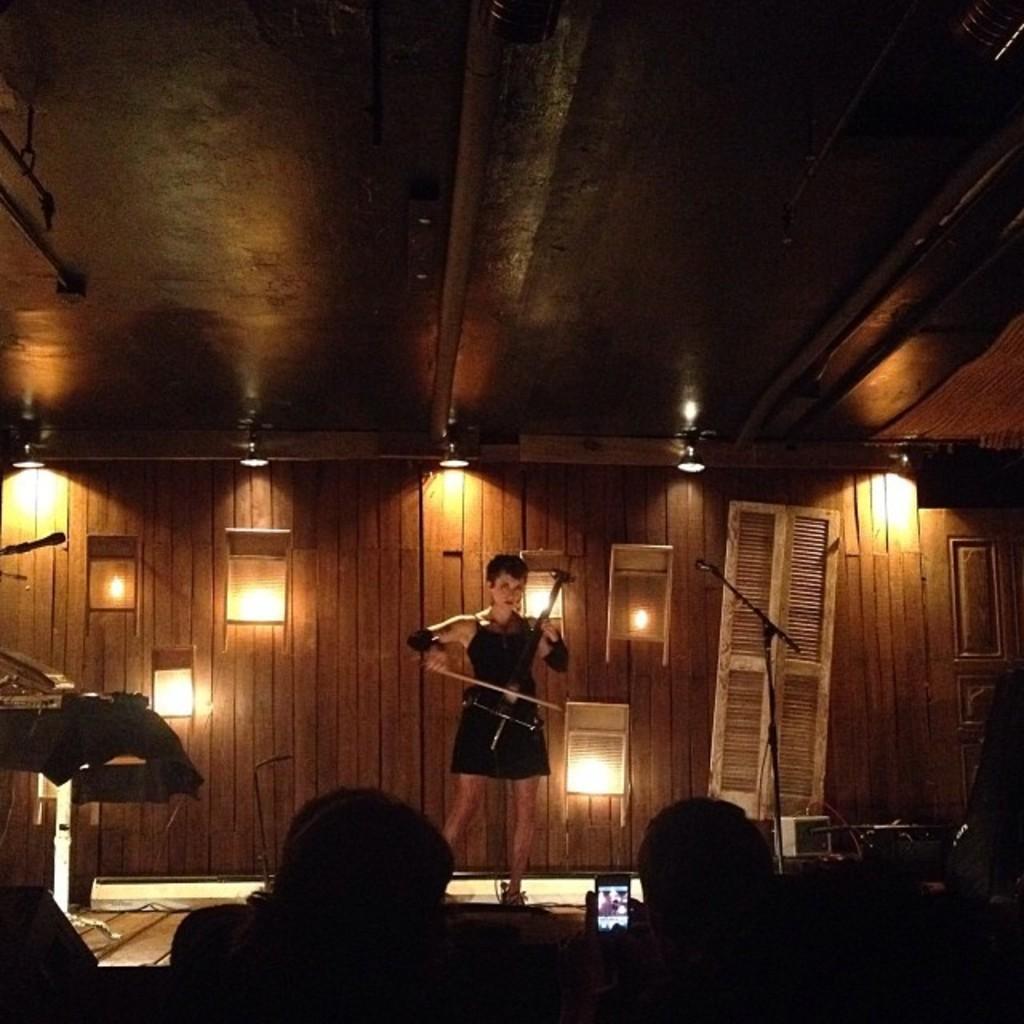Describe this image in one or two sentences. In this picture there is a woman wearing a black dress holding a violin in the hand and standing on the stage. Behind there is a wooden panel wall with some lights and white color wooden door. In front bottom side we can see a group of audience sitting and enjoying the music. 